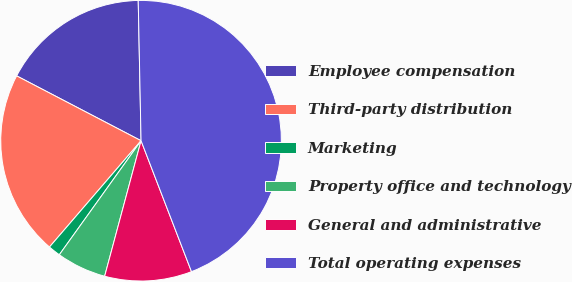Convert chart. <chart><loc_0><loc_0><loc_500><loc_500><pie_chart><fcel>Employee compensation<fcel>Third-party distribution<fcel>Marketing<fcel>Property office and technology<fcel>General and administrative<fcel>Total operating expenses<nl><fcel>17.03%<fcel>21.33%<fcel>1.42%<fcel>5.72%<fcel>10.03%<fcel>44.47%<nl></chart> 